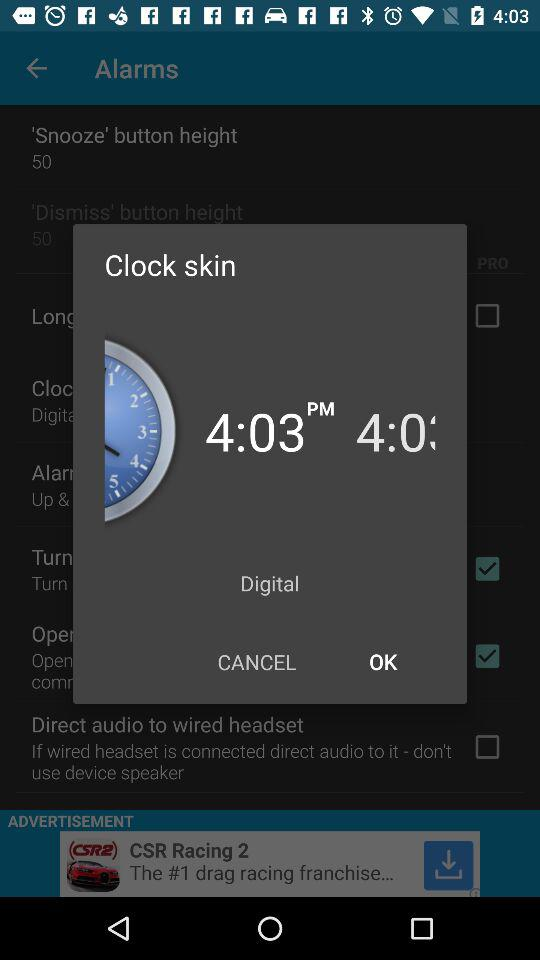What type of clock is it? It is a digital clock. 